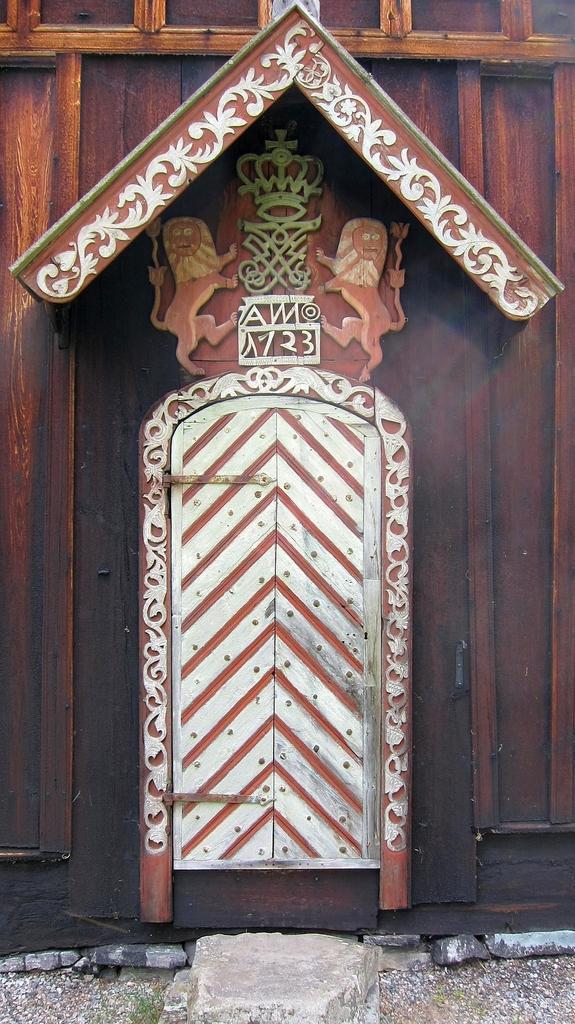How would you summarize this image in a sentence or two? In this picture we can observe a white color gate. There is a brown color wooden wall here. We can observe carving on this wooden wall. There is a stone placed on the land. 